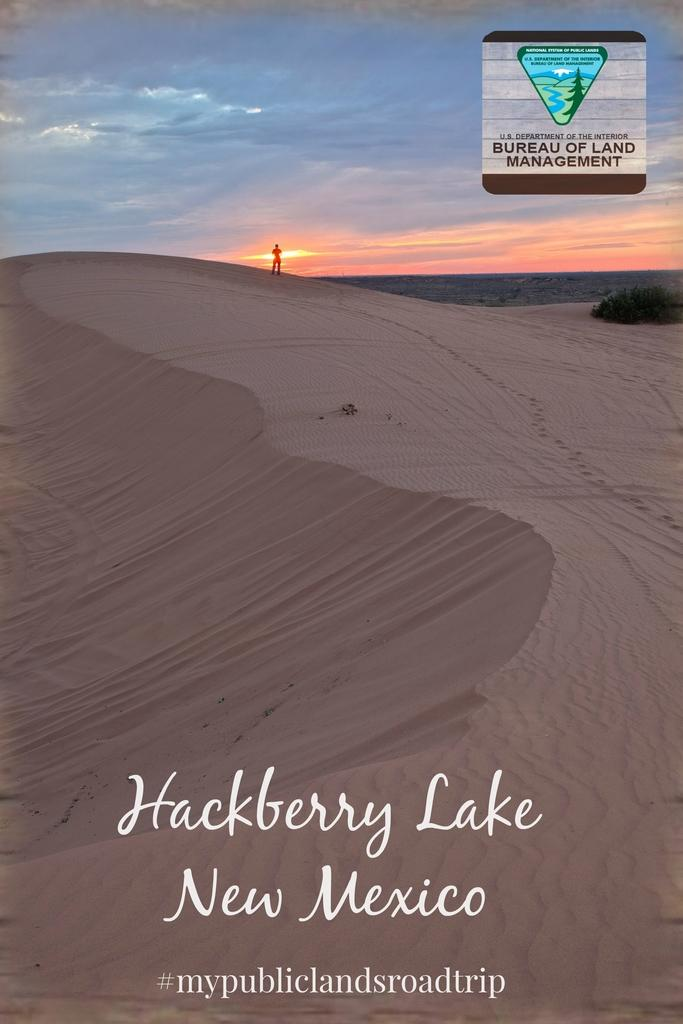<image>
Present a compact description of the photo's key features. A travel guide for Hackberry lake New Mexico by the Bureau of Land Management. 